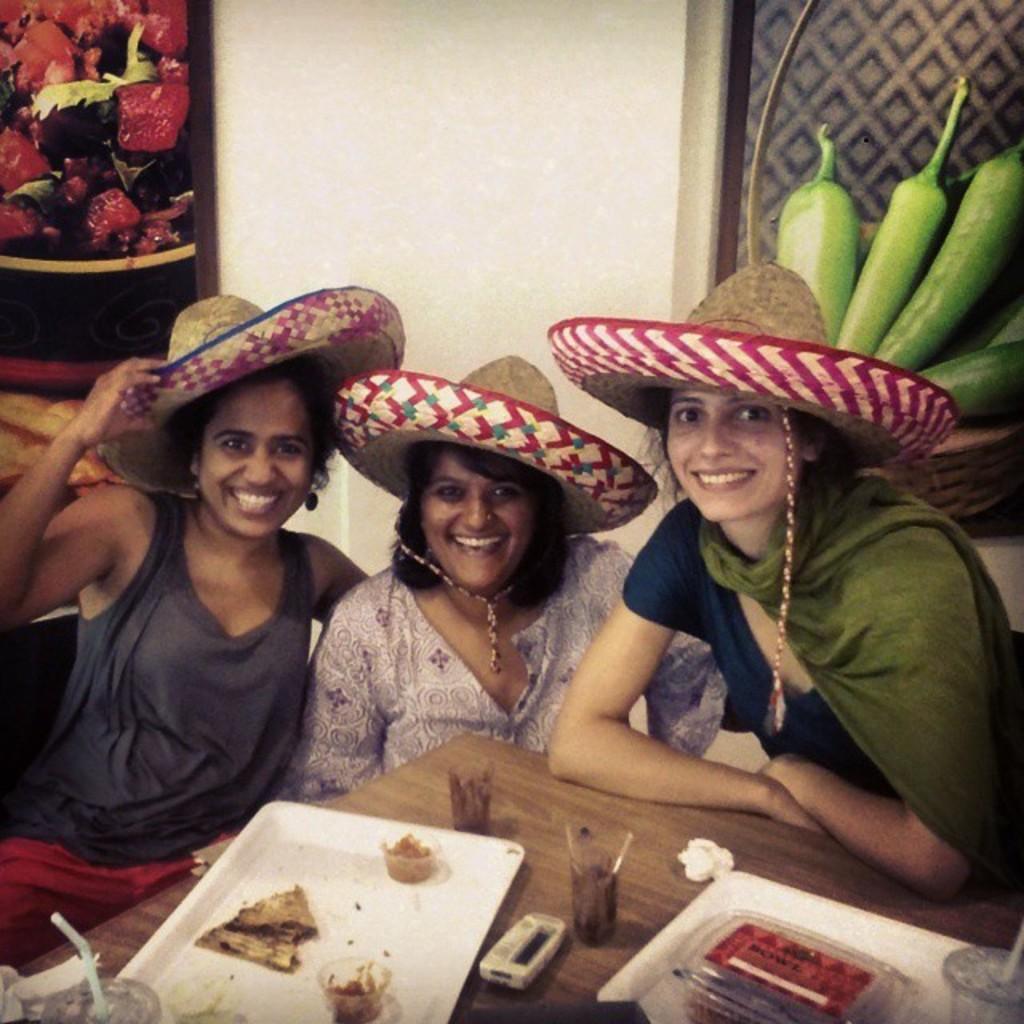In one or two sentences, can you explain what this image depicts? In this image I see 3 women who are sitting and I see that all of them are smiling and wearing hats on their heads and I see a table over here on which there are plates and I see food on them and I see the glasses. In the background I see the wall and I see the red color things and green color things on the sides. 